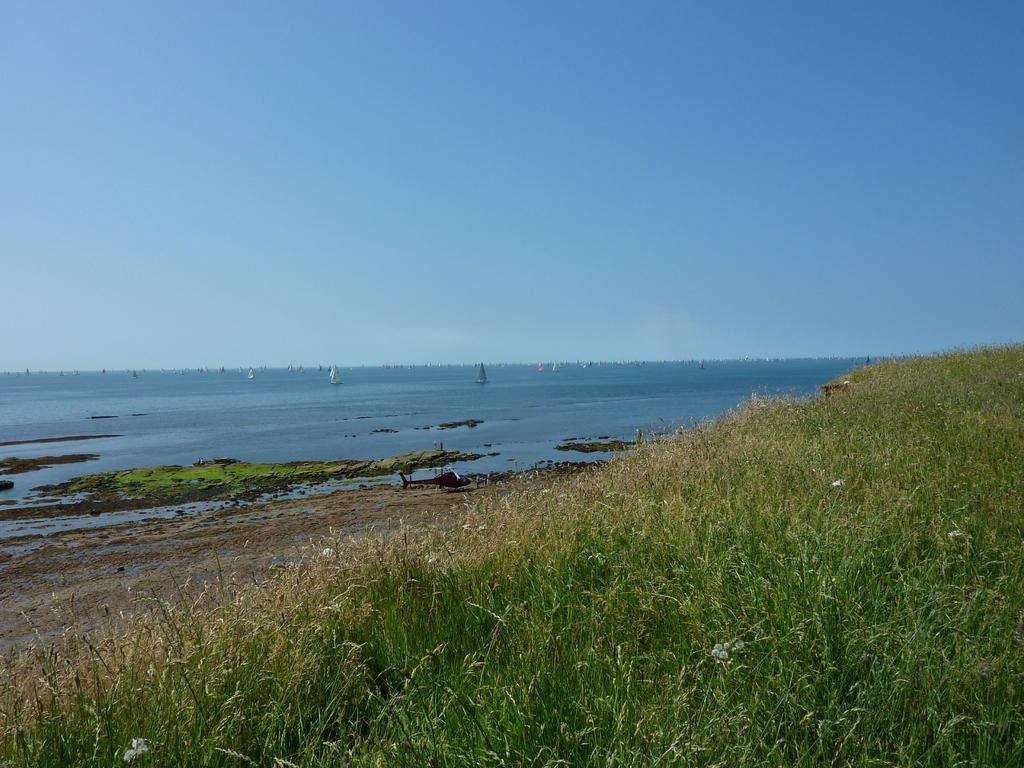What type of living organisms can be seen in the image? Plants can be seen in the image. What mode of transportation is present in the image? There is a helicopter in the image. What is the status of the helicopter in the image? The helicopter is landed on the ground. What natural element is visible in the image? There is water flowing in the image. What objects are floating on the water? There are boats on the water. What type of fork can be seen in the image? There is no fork present in the image. Are there any dolls visible in the image? There are no dolls present in the image. 